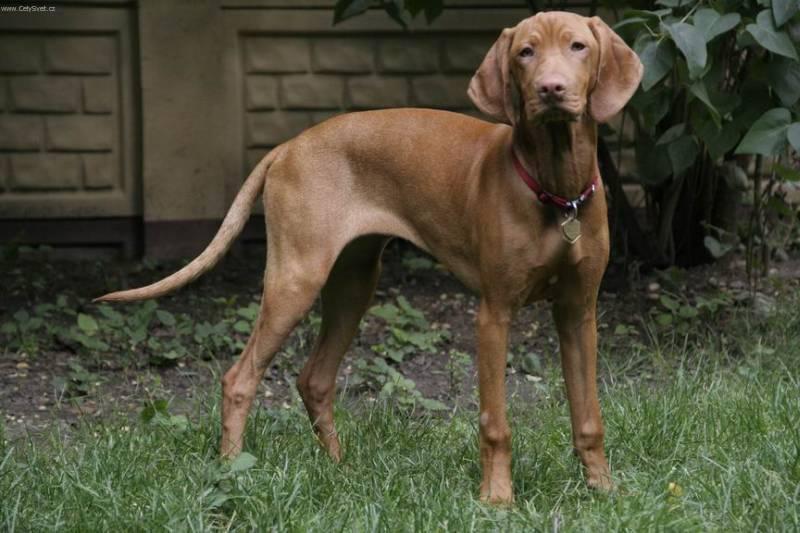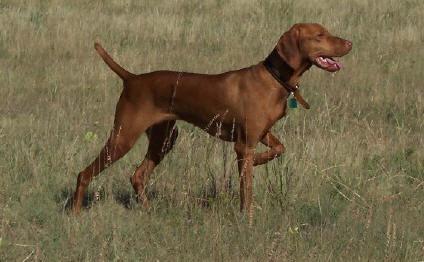The first image is the image on the left, the second image is the image on the right. For the images shown, is this caption "A dog is holding something in its mouth." true? Answer yes or no. No. The first image is the image on the left, the second image is the image on the right. Considering the images on both sides, is "The dog on the left has something held in its mouth, and the dog on the right is standing on green grass with its tail extended." valid? Answer yes or no. No. 